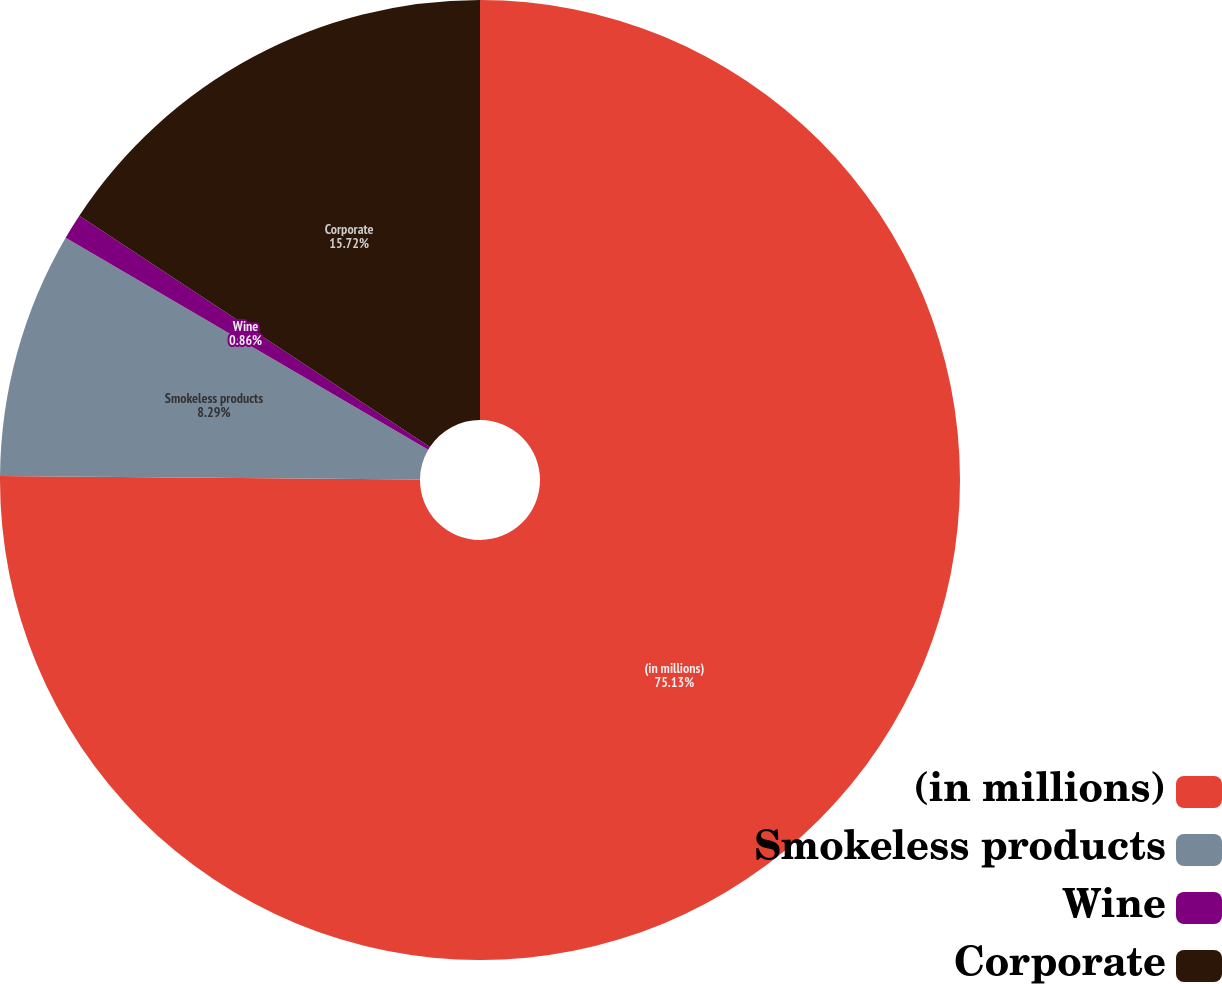Convert chart. <chart><loc_0><loc_0><loc_500><loc_500><pie_chart><fcel>(in millions)<fcel>Smokeless products<fcel>Wine<fcel>Corporate<nl><fcel>75.14%<fcel>8.29%<fcel>0.86%<fcel>15.72%<nl></chart> 